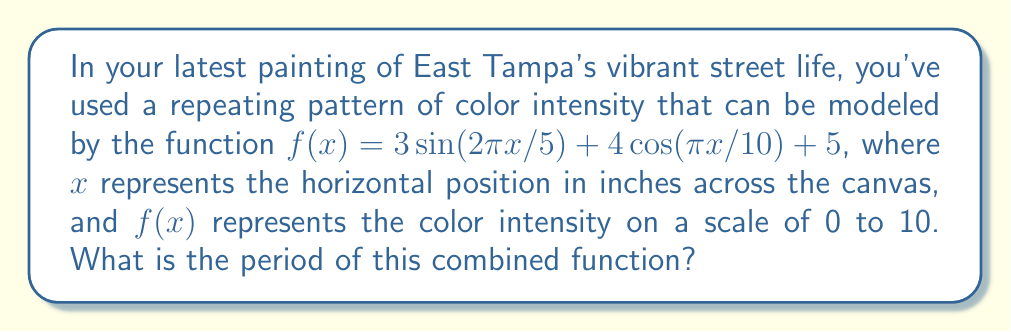Can you answer this question? To find the period of the combined function, we need to follow these steps:

1) First, identify the periods of each component:
   For $3\sin(2\pi x/5)$:
   Period = $\frac{2\pi}{\left|\frac{2\pi}{5}\right|} = 5$

   For $4\cos(\pi x/10)$:
   Period = $\frac{2\pi}{\left|\frac{\pi}{10}\right|} = 20$

2) The constant term 5 doesn't affect the period.

3) To find the period of the combined function, we need to find the least common multiple (LCM) of the individual periods:

   LCM(5, 20) = 20

Therefore, the combined function will repeat every 20 inches across the canvas.

4) To verify, we can check:
   $f(x+20) = 3\sin(2\pi(x+20)/5) + 4\cos(\pi(x+20)/10) + 5$
             $= 3\sin(2\pi x/5 + 8\pi) + 4\cos(\pi x/10 + 2\pi) + 5$
             $= 3\sin(2\pi x/5) + 4\cos(\pi x/10) + 5$
             $= f(x)$

This confirms that the function indeed repeats every 20 inches.
Answer: 20 inches 